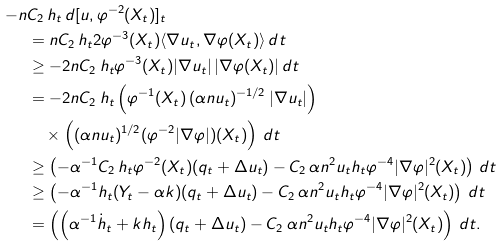<formula> <loc_0><loc_0><loc_500><loc_500>- n & C _ { 2 } \, h _ { t } \, d [ u , \varphi ^ { - 2 } ( X _ { t } ) ] _ { t } \\ & = n C _ { 2 } \, h _ { t } 2 \varphi ^ { - 3 } ( X _ { t } ) \langle \nabla u _ { t } , \nabla \varphi ( X _ { t } ) \rangle \, d t \\ & \geq - 2 n C _ { 2 } \, h _ { t } \varphi ^ { - 3 } ( X _ { t } ) | \nabla u _ { t } | \, | \nabla \varphi ( X _ { t } ) | \, d t \\ & = - 2 n C _ { 2 } \, h _ { t } \left ( \varphi ^ { - 1 } ( X _ { t } ) \, ( \alpha n u _ { t } ) ^ { - 1 / 2 } \, | \nabla u _ { t } | \right ) \\ & \quad \times \left ( ( \alpha n u _ { t } ) ^ { 1 / 2 } ( \varphi ^ { - 2 } | \nabla \varphi | ) ( X _ { t } ) \right ) \, d t \\ & \geq \left ( - \alpha ^ { - 1 } C _ { 2 } \, h _ { t } \varphi ^ { - 2 } ( X _ { t } ) ( q _ { t } + \Delta u _ { t } ) - C _ { 2 } \, \alpha n ^ { 2 } u _ { t } h _ { t } \varphi ^ { - 4 } | \nabla \varphi | ^ { 2 } ( X _ { t } ) \right ) \, d t \\ & \geq \left ( - \alpha ^ { - 1 } h _ { t } ( Y _ { t } - \alpha k ) ( q _ { t } + \Delta u _ { t } ) - C _ { 2 } \, \alpha n ^ { 2 } u _ { t } h _ { t } \varphi ^ { - 4 } | \nabla \varphi | ^ { 2 } ( X _ { t } ) \right ) \, d t \\ & = \left ( \left ( \alpha ^ { - 1 } \dot { h } _ { t } + k h _ { t } \right ) ( q _ { t } + \Delta u _ { t } ) - C _ { 2 } \, \alpha n ^ { 2 } u _ { t } h _ { t } \varphi ^ { - 4 } | \nabla \varphi | ^ { 2 } ( X _ { t } ) \right ) \, d t .</formula> 